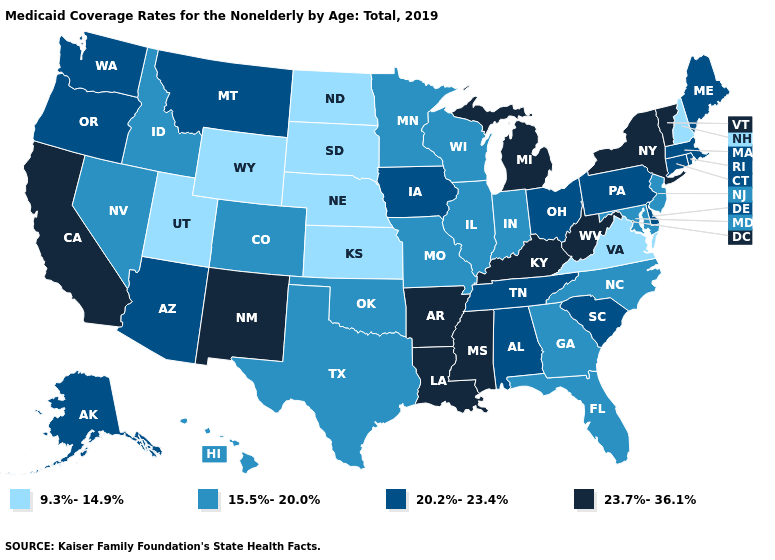What is the lowest value in the West?
Short answer required. 9.3%-14.9%. Name the states that have a value in the range 20.2%-23.4%?
Quick response, please. Alabama, Alaska, Arizona, Connecticut, Delaware, Iowa, Maine, Massachusetts, Montana, Ohio, Oregon, Pennsylvania, Rhode Island, South Carolina, Tennessee, Washington. Which states hav the highest value in the MidWest?
Be succinct. Michigan. Name the states that have a value in the range 9.3%-14.9%?
Be succinct. Kansas, Nebraska, New Hampshire, North Dakota, South Dakota, Utah, Virginia, Wyoming. What is the value of Wyoming?
Answer briefly. 9.3%-14.9%. Name the states that have a value in the range 23.7%-36.1%?
Quick response, please. Arkansas, California, Kentucky, Louisiana, Michigan, Mississippi, New Mexico, New York, Vermont, West Virginia. Does Michigan have the highest value in the MidWest?
Quick response, please. Yes. Which states have the lowest value in the USA?
Answer briefly. Kansas, Nebraska, New Hampshire, North Dakota, South Dakota, Utah, Virginia, Wyoming. Does Idaho have a lower value than Washington?
Give a very brief answer. Yes. What is the highest value in the MidWest ?
Give a very brief answer. 23.7%-36.1%. Does New York have the highest value in the Northeast?
Be succinct. Yes. Does Virginia have a higher value than Idaho?
Quick response, please. No. Does Tennessee have the lowest value in the USA?
Keep it brief. No. 